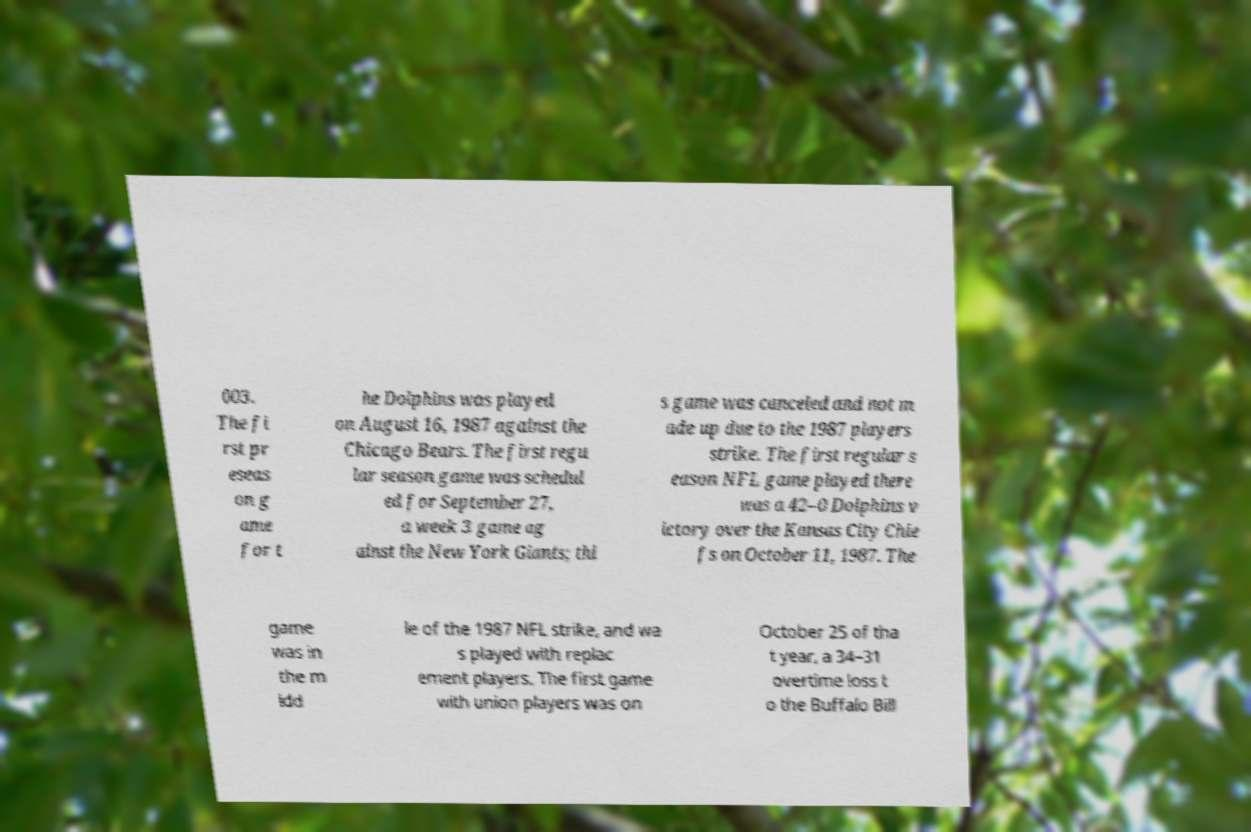There's text embedded in this image that I need extracted. Can you transcribe it verbatim? 003. The fi rst pr eseas on g ame for t he Dolphins was played on August 16, 1987 against the Chicago Bears. The first regu lar season game was schedul ed for September 27, a week 3 game ag ainst the New York Giants; thi s game was canceled and not m ade up due to the 1987 players strike. The first regular s eason NFL game played there was a 42–0 Dolphins v ictory over the Kansas City Chie fs on October 11, 1987. The game was in the m idd le of the 1987 NFL strike, and wa s played with replac ement players. The first game with union players was on October 25 of tha t year, a 34–31 overtime loss t o the Buffalo Bill 